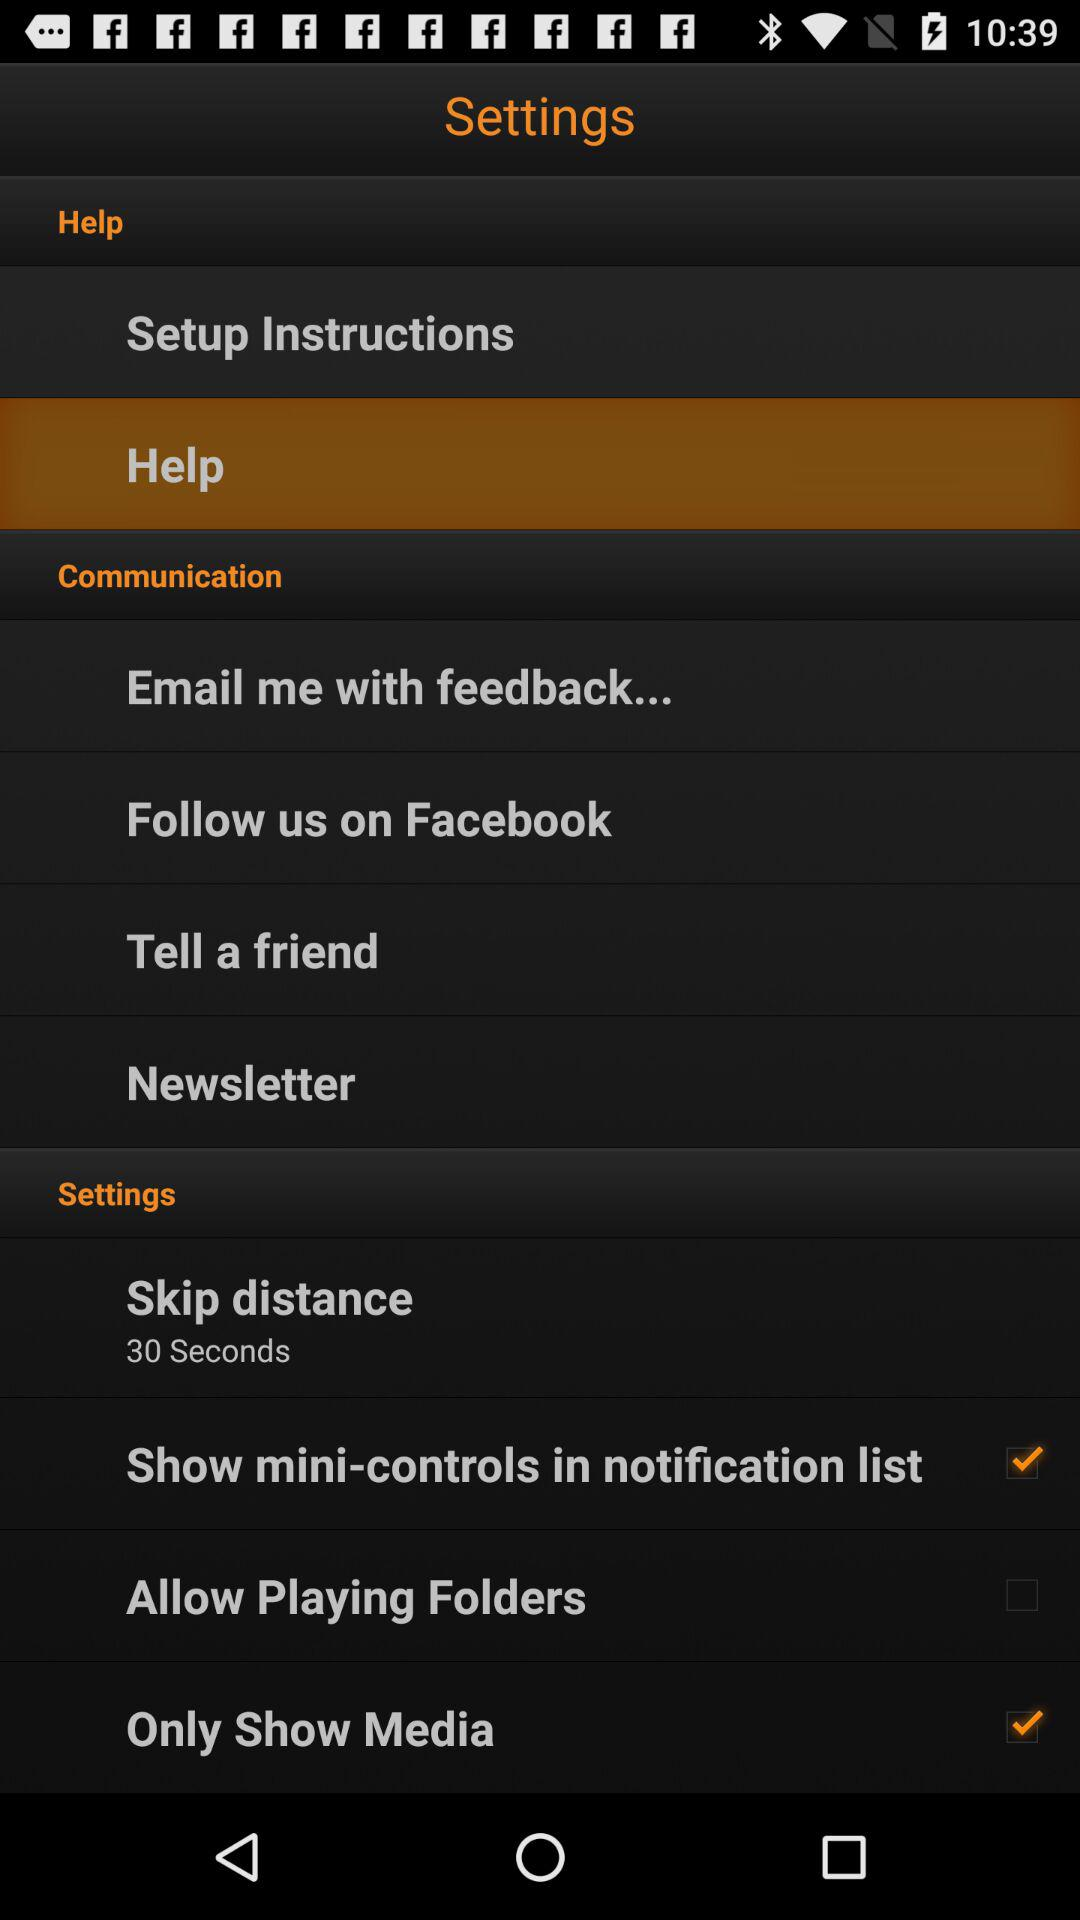What is the time duration for "Skip distance"? The time duration is 30 seconds. 